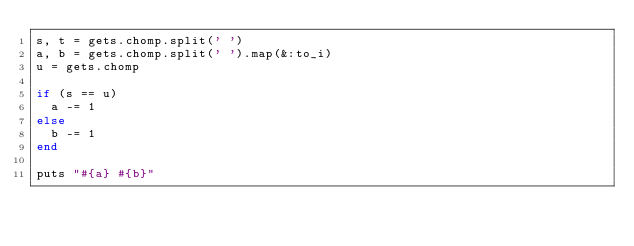Convert code to text. <code><loc_0><loc_0><loc_500><loc_500><_Ruby_>s, t = gets.chomp.split(' ')
a, b = gets.chomp.split(' ').map(&:to_i)
u = gets.chomp

if (s == u)
  a -= 1
else
  b -= 1
end

puts "#{a} #{b}"
</code> 